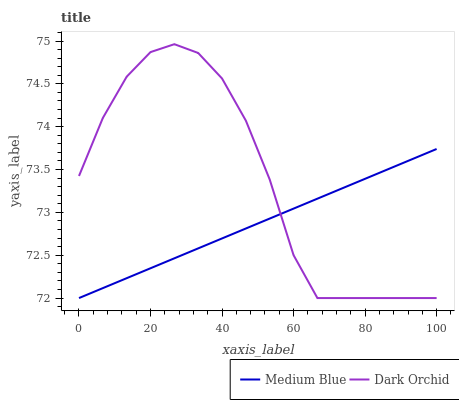Does Medium Blue have the minimum area under the curve?
Answer yes or no. Yes. Does Dark Orchid have the maximum area under the curve?
Answer yes or no. Yes. Does Dark Orchid have the minimum area under the curve?
Answer yes or no. No. Is Medium Blue the smoothest?
Answer yes or no. Yes. Is Dark Orchid the roughest?
Answer yes or no. Yes. Is Dark Orchid the smoothest?
Answer yes or no. No. Does Dark Orchid have the highest value?
Answer yes or no. Yes. 